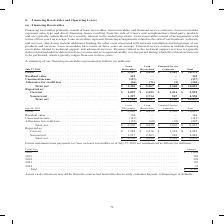According to Cisco Systems's financial document, What did financing receivables primarily consist of? lease receivables, loan receivables, and financed service contracts.. The document states: "Financing receivables primarily consist of lease receivables, loan receivables, and financed service contracts. Lease receivables represent sales-type..." Also, What did financed service contracts include? financing receivables related to technical support and advanced services. The document states: "rs on average. Financed service contracts include financing receivables related to technical support and advanced services. Revenue related to the tec..." Also, What was unearned income from lease receivables in 2019? According to the financial document, (137) (in millions). The relevant text states: "174 Residual value . 142 — — 142 Unearned income . (137) — — (137 ) Allowance for credit loss . (46) (71) (9) (126 ) Total, net . $ 2,326 $ 5,367 $ 2,360 $ 1..." Also, can you calculate: What was the difference in the reported total between current and noncurrent financing receivables? Based on the calculation: 5,095-4,958, the result is 137 (in millions). This is based on the information: "Reported as: Current . $ 1,029 $ 2,653 $ 1,413 $ 5,095 Noncurrent . 1,297 2,714 947 4,958 Total, net . $ 2,326 $ 5,367 $ 2,360 $ 10,053 ,653 $ 1,413 $ 5,095 Noncurrent . 1,297 2,714 947 4,958 Total, n..." The key data points involved are: 4,958, 5,095. Also, can you calculate: What was the difference in the net total between Lease and Loan Receivables? Based on the calculation: 5,367-2,326, the result is 3041 (in millions). This is based on the information: "oss . (46) (71) (9) (126 ) Total, net . $ 2,326 $ 5,367 $ 2,360 $ 10,053 Reported as: Current . $ 1,029 $ 2,653 $ 1,413 $ 5,095 Noncurrent . 1,297 2,714 94 credit loss . (46) (71) (9) (126 ) Total, ne..." The key data points involved are: 2,326, 5,367. Also, How many types of financing receivables had a net total that exceeded $5,000 million? Based on the analysis, there are 1 instances. The counting process: Loan Receivables. 